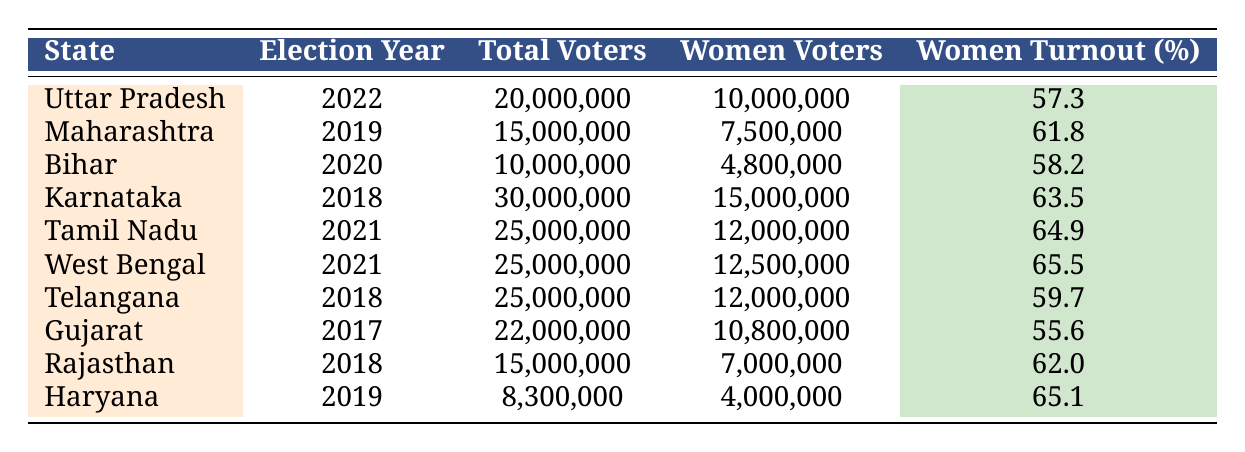What was the voter turnout percentage for women in Uttar Pradesh during the 2022 elections? According to the table, Uttar Pradesh had a women turnout percentage of 57.3% in the 2022 elections. This information is directly available in the corresponding row.
Answer: 57.3% Which state had the highest women voter turnout percentage, and what was that percentage? Looking through the table, West Bengal recorded the highest women voter turnout percentage of 65.5% during the 2021 elections, as indicated in the respective row.
Answer: 65.5% in West Bengal What is the total number of women voters in Karnataka for the 2018 elections? The table specifies that there were 15,000,000 women voters in Karnataka during the 2018 elections, which can be easily found in the relevant row.
Answer: 15,000,000 What is the difference between the total number of women voters in Tamil Nadu and Haryana? Tamil Nadu had 12,000,000 women voters while Haryana had 4,000,000. The difference is calculated by subtracting the number of women voters in Haryana from that in Tamil Nadu: 12,000,000 - 4,000,000 = 8,000,000.
Answer: 8,000,000 Are the women voter turnout percentages in Telangana and Gujarat higher than 60%? In the table, Telangana has a women turnout percentage of 59.7% and Gujarat has 55.6%. Neither percentage exceeds 60%, confirming the answer is no.
Answer: No What was the average voter turnout percentage for women across all listed states? First, we need to sum all the women turnout percentages: 57.3 + 61.8 + 58.2 + 63.5 + 64.9 + 65.5 + 59.7 + 55.6 + 62.0 + 65.1 =  604.6%. Next, divide this sum by the number of states (10): 604.6 / 10 = 60.46%.
Answer: 60.46% Which state had the least number of women voters and what was that number? According to the table, Bihar had the least number of women voters at 4,800,000 during the 2020 elections, as shown in the relevant row.
Answer: 4,800,000 Did more than 60% of women voters turn out in Rajasthan during the 2018 elections? The table shows that women turnout in Rajasthan was 62.0%, which is higher than 60%. Therefore, the answer is yes.
Answer: Yes 